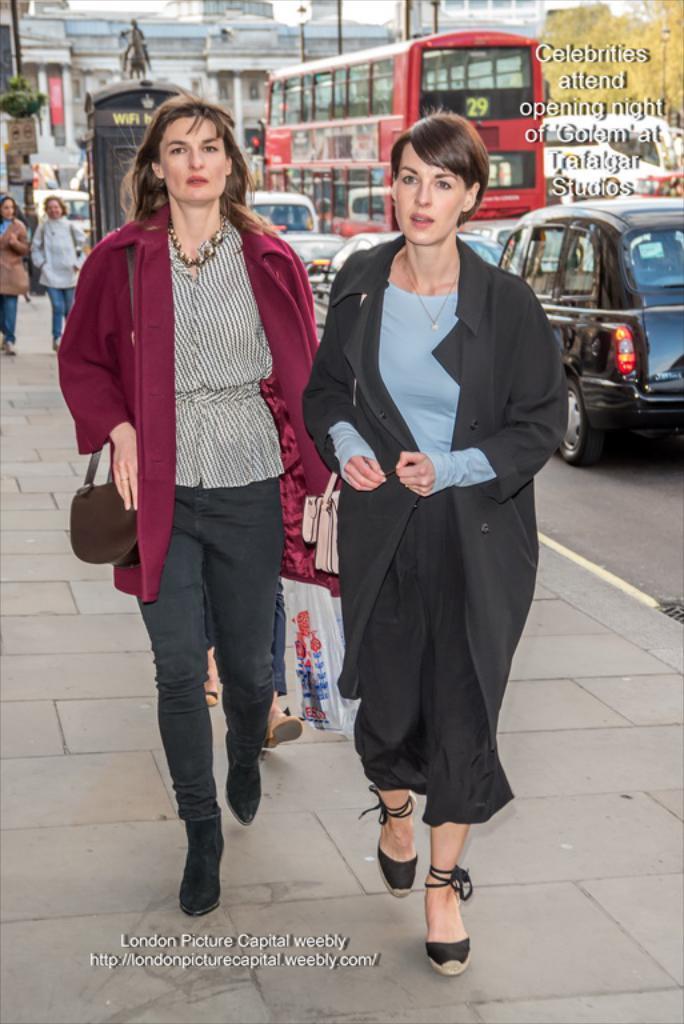How would you summarize this image in a sentence or two? As we can see in the image there are few people here and there, cars, bus and building. In the front there are two women walking. The woman on the right side is wearing black color dress and the woman on the left side is wearing red color jacket and holding a bag. 